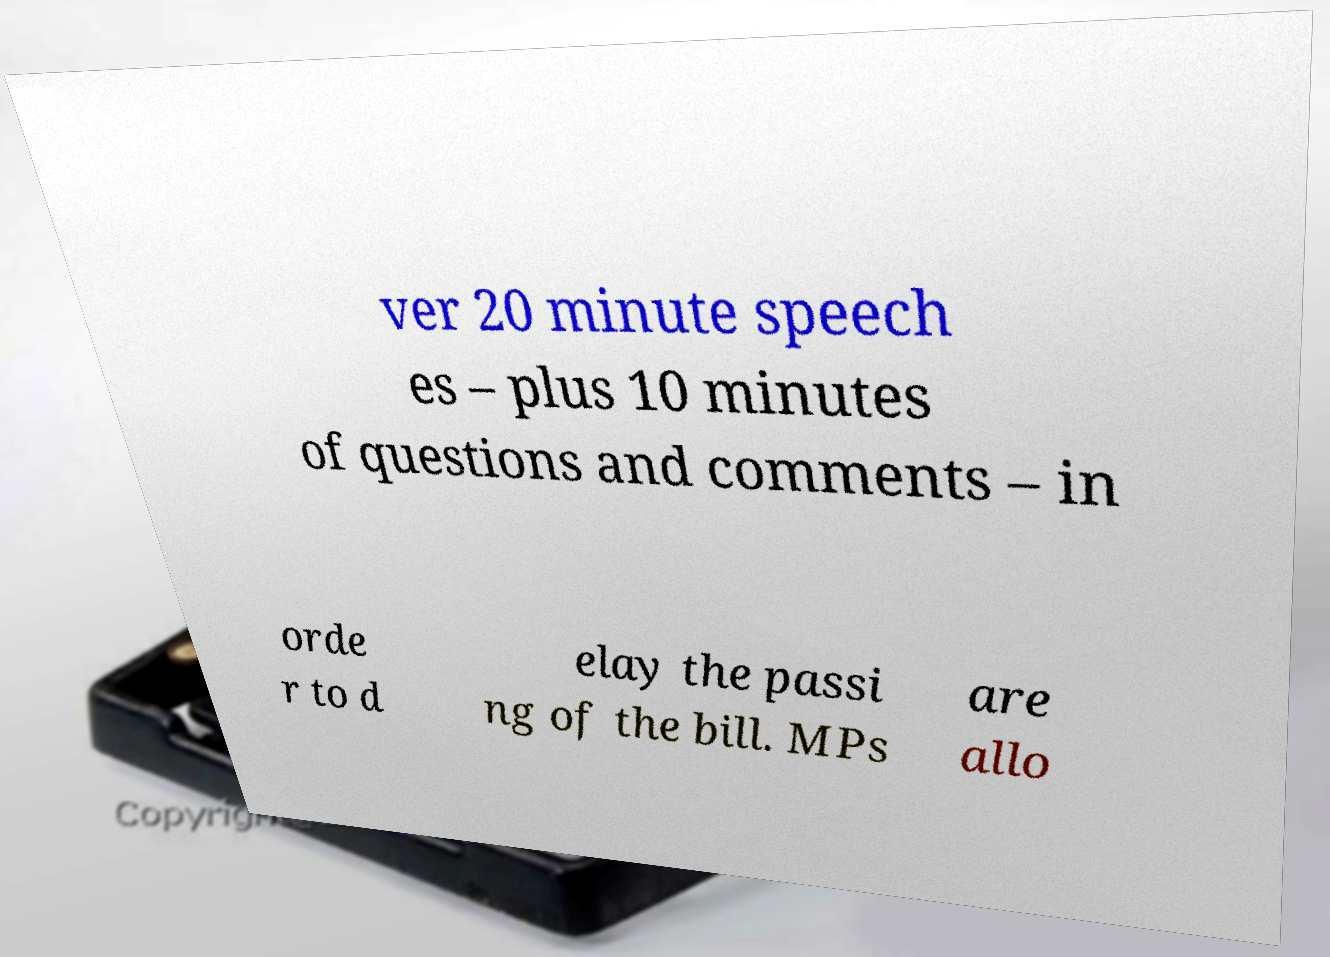Could you extract and type out the text from this image? ver 20 minute speech es – plus 10 minutes of questions and comments – in orde r to d elay the passi ng of the bill. MPs are allo 